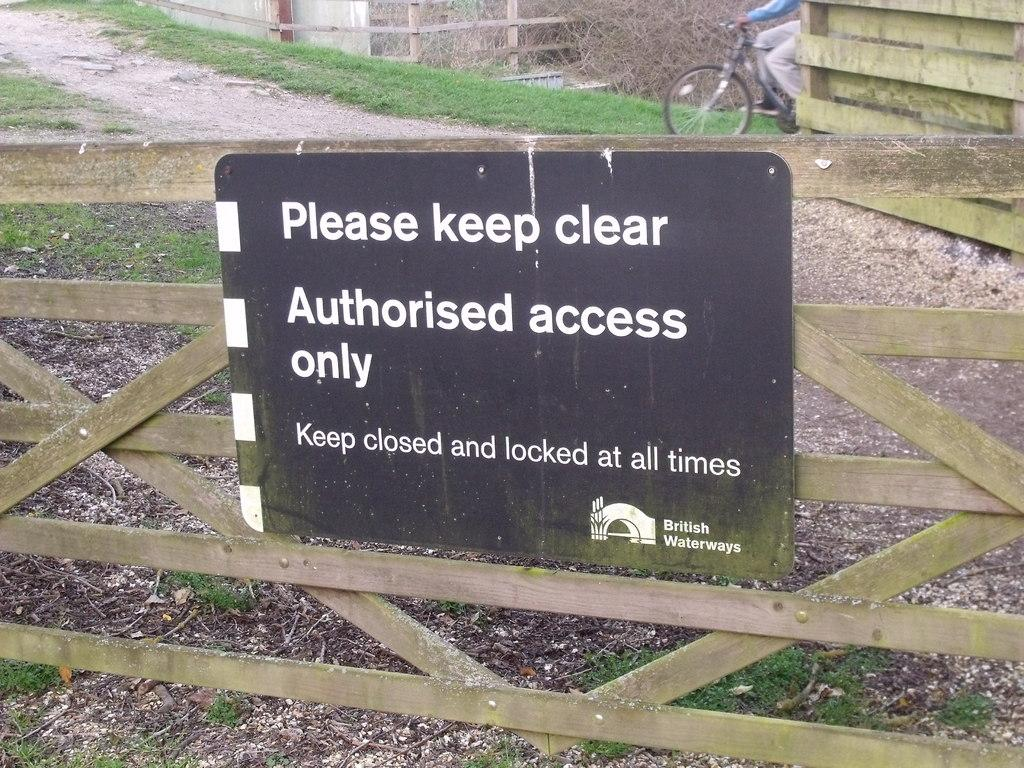What is the main object in the image? There is an information board in the image. How is the information board attached? The information board is attached to a wooden grill. What can be seen on the ground in the image? The ground is visible in the image, and there is grass present. What activity is being performed by the person in the image? There is a person riding a bicycle in the image. How many apples are being used as decorations on the information board? There are no apples present on the information board in the image. What type of work is the person on the bicycle doing? The image does not provide information about the person's work or occupation. 